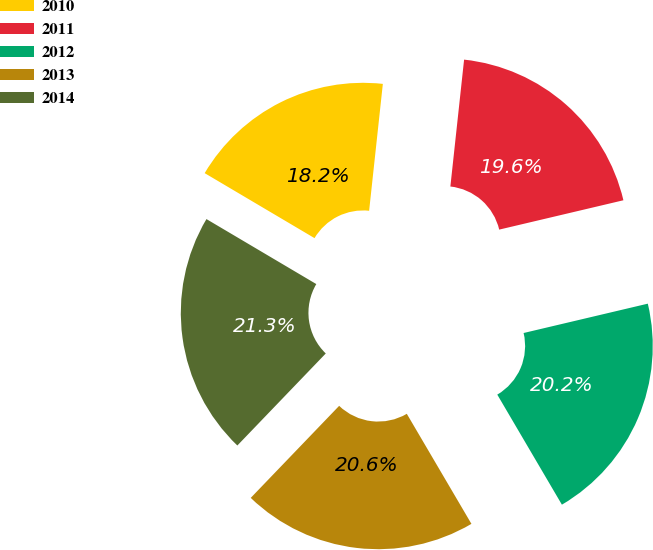<chart> <loc_0><loc_0><loc_500><loc_500><pie_chart><fcel>2010<fcel>2011<fcel>2012<fcel>2013<fcel>2014<nl><fcel>18.21%<fcel>19.59%<fcel>20.24%<fcel>20.63%<fcel>21.32%<nl></chart> 